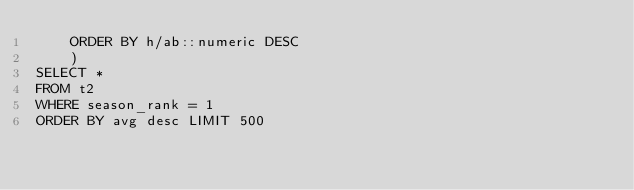<code> <loc_0><loc_0><loc_500><loc_500><_SQL_>    ORDER BY h/ab::numeric DESC
    )
SELECT *
FROM t2
WHERE season_rank = 1
ORDER BY avg desc LIMIT 500
</code> 